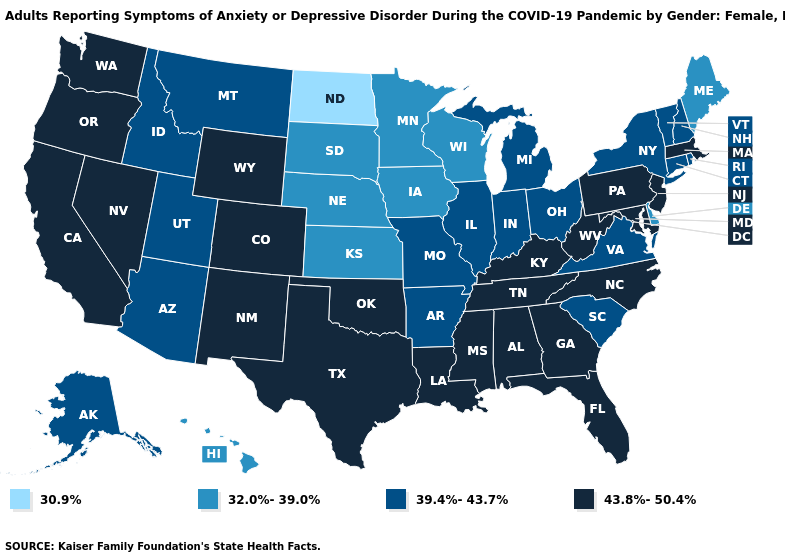Does Washington have the lowest value in the West?
Concise answer only. No. Is the legend a continuous bar?
Quick response, please. No. What is the lowest value in the Northeast?
Answer briefly. 32.0%-39.0%. What is the value of Connecticut?
Quick response, please. 39.4%-43.7%. Among the states that border Louisiana , which have the lowest value?
Be succinct. Arkansas. What is the value of Minnesota?
Write a very short answer. 32.0%-39.0%. What is the lowest value in the South?
Answer briefly. 32.0%-39.0%. How many symbols are there in the legend?
Write a very short answer. 4. Is the legend a continuous bar?
Keep it brief. No. Does New York have the highest value in the Northeast?
Quick response, please. No. Does Minnesota have a lower value than Connecticut?
Keep it brief. Yes. Which states have the highest value in the USA?
Keep it brief. Alabama, California, Colorado, Florida, Georgia, Kentucky, Louisiana, Maryland, Massachusetts, Mississippi, Nevada, New Jersey, New Mexico, North Carolina, Oklahoma, Oregon, Pennsylvania, Tennessee, Texas, Washington, West Virginia, Wyoming. Name the states that have a value in the range 43.8%-50.4%?
Quick response, please. Alabama, California, Colorado, Florida, Georgia, Kentucky, Louisiana, Maryland, Massachusetts, Mississippi, Nevada, New Jersey, New Mexico, North Carolina, Oklahoma, Oregon, Pennsylvania, Tennessee, Texas, Washington, West Virginia, Wyoming. Does Ohio have the highest value in the MidWest?
Quick response, please. Yes. Which states have the highest value in the USA?
Quick response, please. Alabama, California, Colorado, Florida, Georgia, Kentucky, Louisiana, Maryland, Massachusetts, Mississippi, Nevada, New Jersey, New Mexico, North Carolina, Oklahoma, Oregon, Pennsylvania, Tennessee, Texas, Washington, West Virginia, Wyoming. 